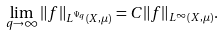<formula> <loc_0><loc_0><loc_500><loc_500>\lim _ { q \rightarrow \infty } \| f \| _ { L ^ { \Psi _ { q } } ( X , \mu ) } = C \| f \| _ { L ^ { \infty } ( X , \mu ) } .</formula> 